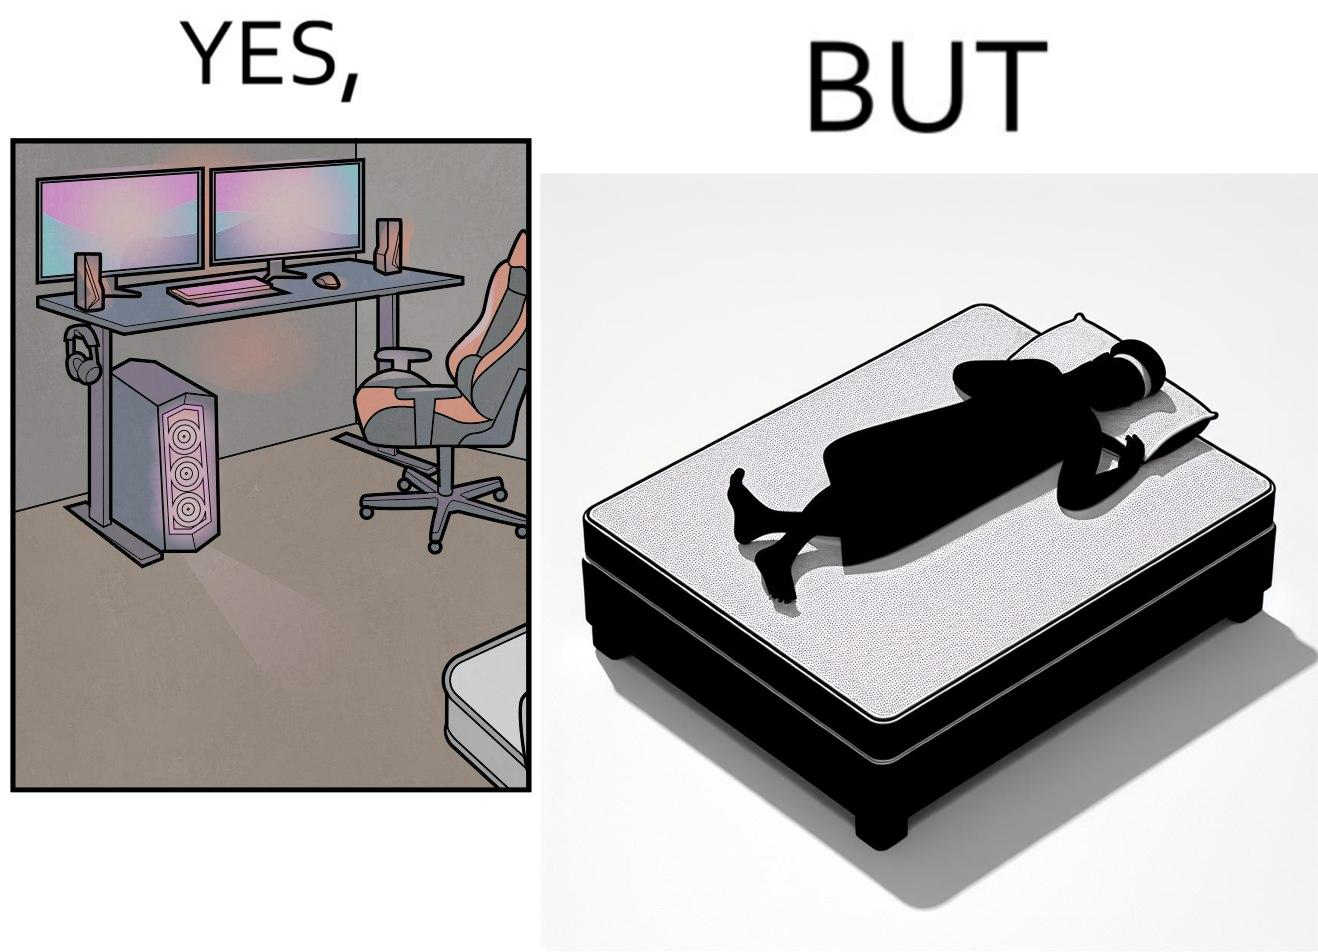What do you see in each half of this image? In the left part of the image: The image shows a computer desk with two monitors, two speakers on the side, a headphone hanging off the side of the table, a cpu on the floor with lights glowing on the front of the cpu and a very comfortable looking gaming chair. The whole setup looks high end and expensive. In the right part of the image: The image shows a man sleeping on a mattress on the floor. There does not seem to be a bedsheet on the mattress. 